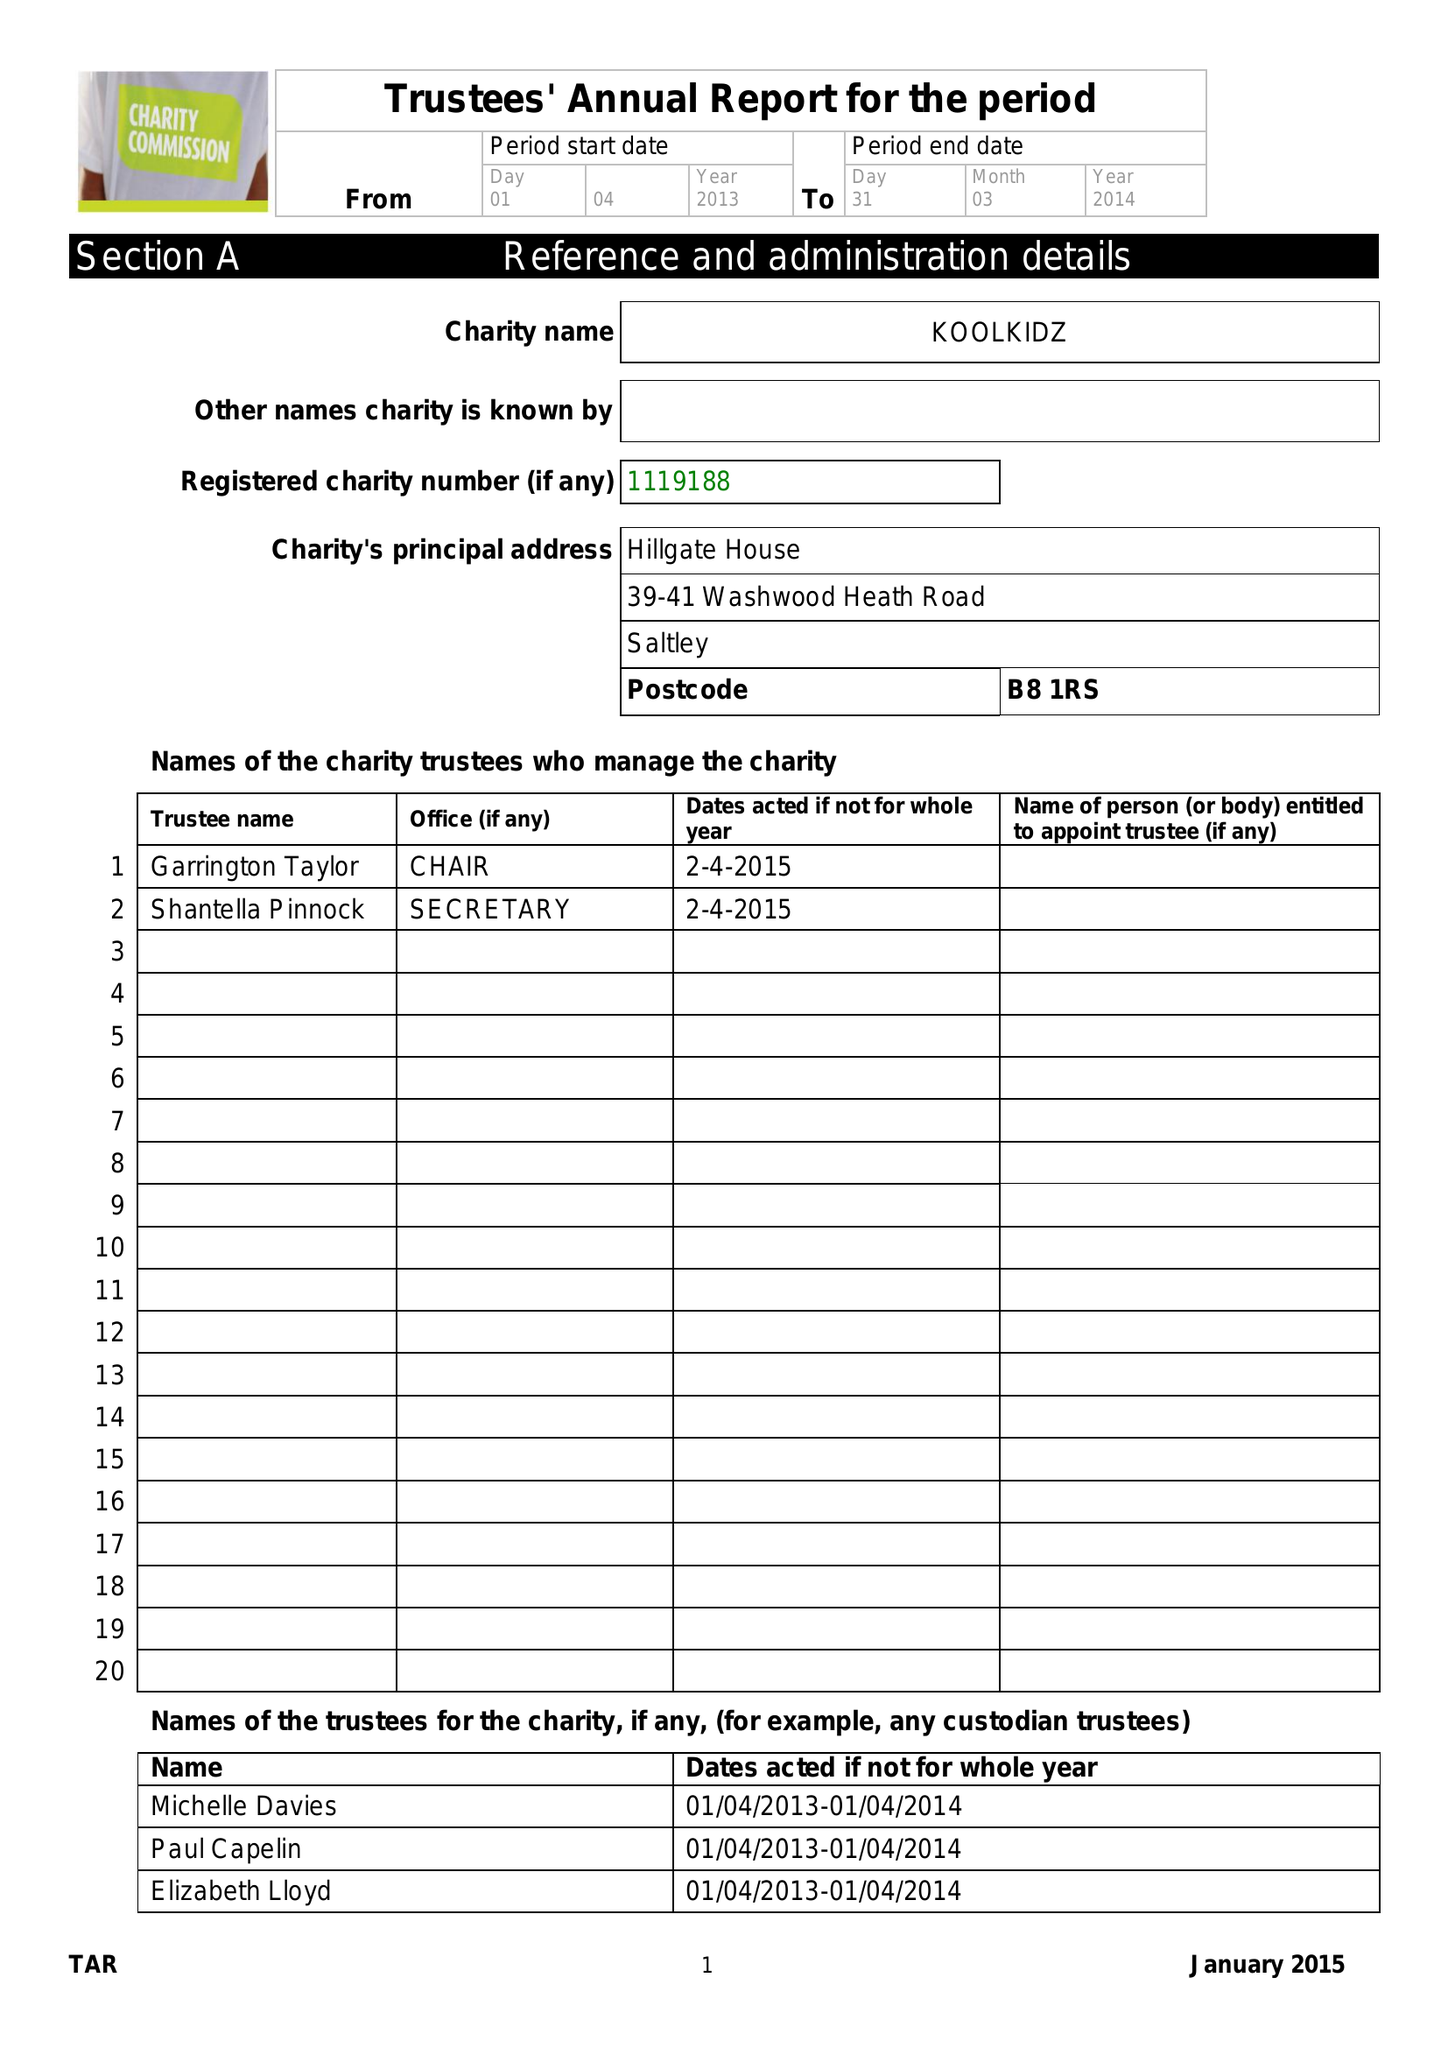What is the value for the income_annually_in_british_pounds?
Answer the question using a single word or phrase. 250123.00 